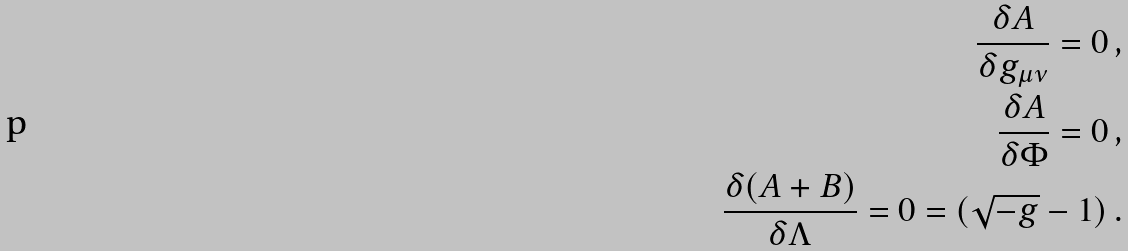Convert formula to latex. <formula><loc_0><loc_0><loc_500><loc_500>\frac { \delta A } { \delta g _ { \mu \nu } } = 0 \, , \\ \frac { \delta A } { \delta \Phi } = 0 \, , \\ \frac { \delta ( A + B ) } { \delta \Lambda } = 0 = ( \sqrt { - g } - 1 ) \, .</formula> 